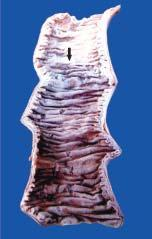what is swollen, dark in colour and coated with fibrinous exudate?
Answer the question using a single word or phrase. Infarcted area 